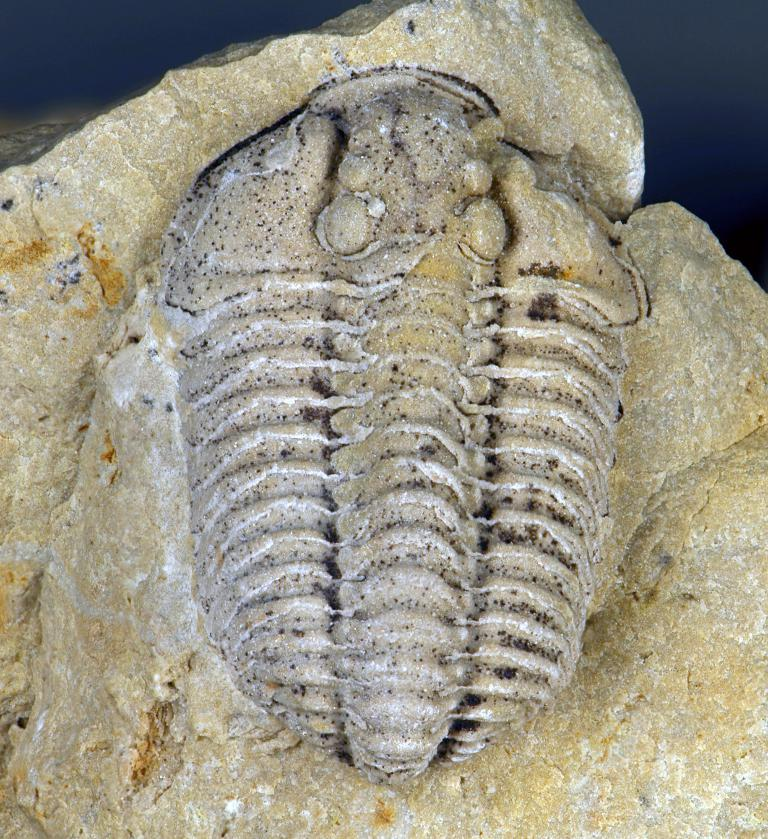What type of fossil is present in the image? The image contains a mold fossil. What is the color of the mold fossil? The mold fossil is in pale brown color. What color is the background of the image? The background of the image is black. Is the queen present in the image? There is no queen depicted in the image; it features a mold fossil against a black background. What type of cast can be seen in the image? There is no cast present in the image; it features a mold fossil against a black background. 